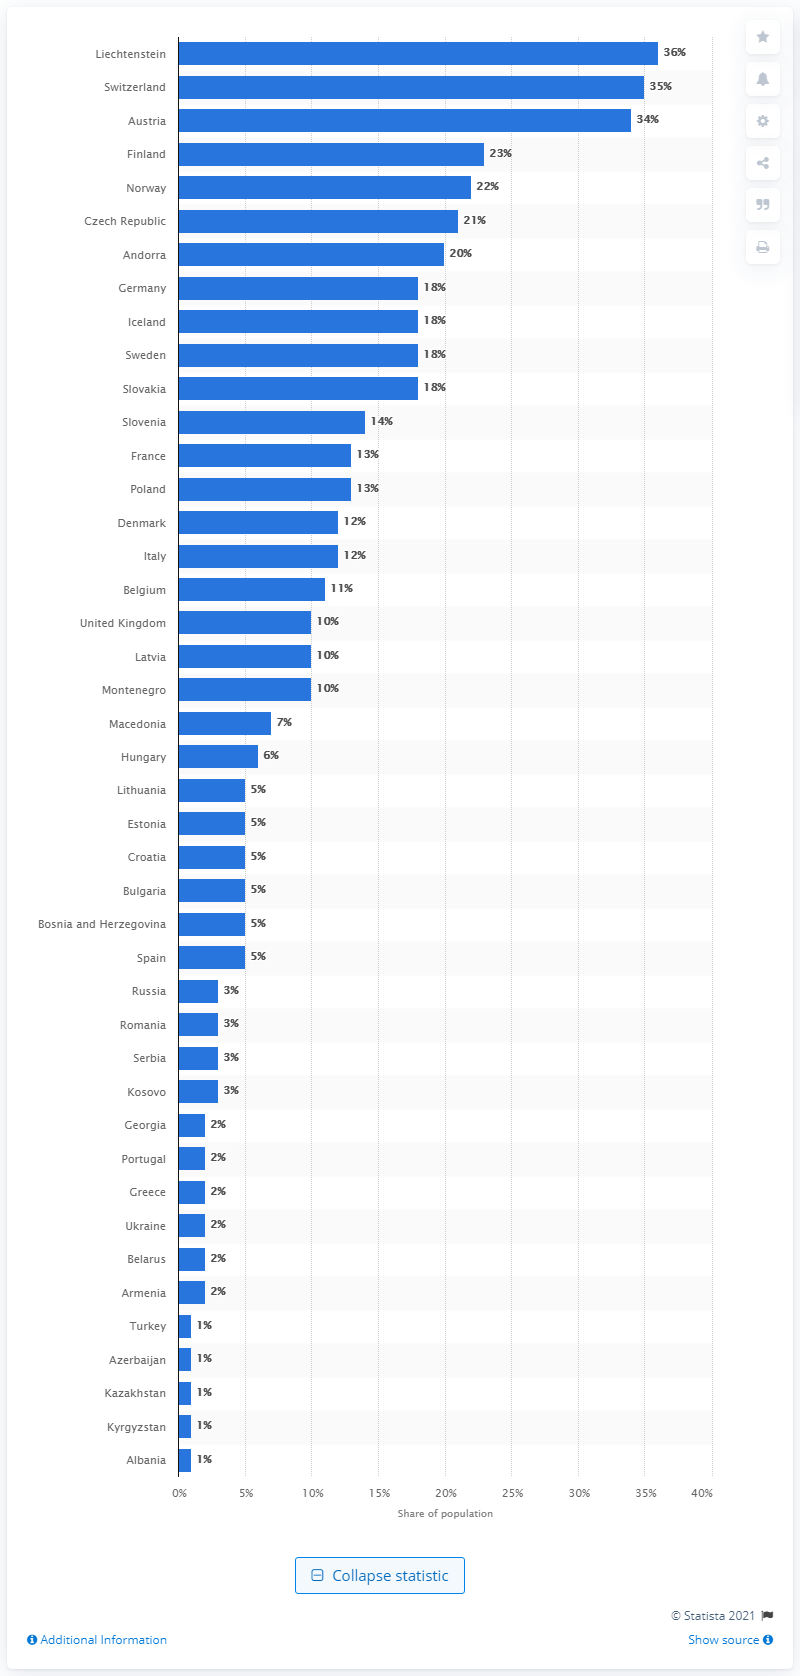Mention a couple of crucial points in this snapshot. The annual survey in the United Kingdom has shown how participation in different snow sport activities has changed over several years. 